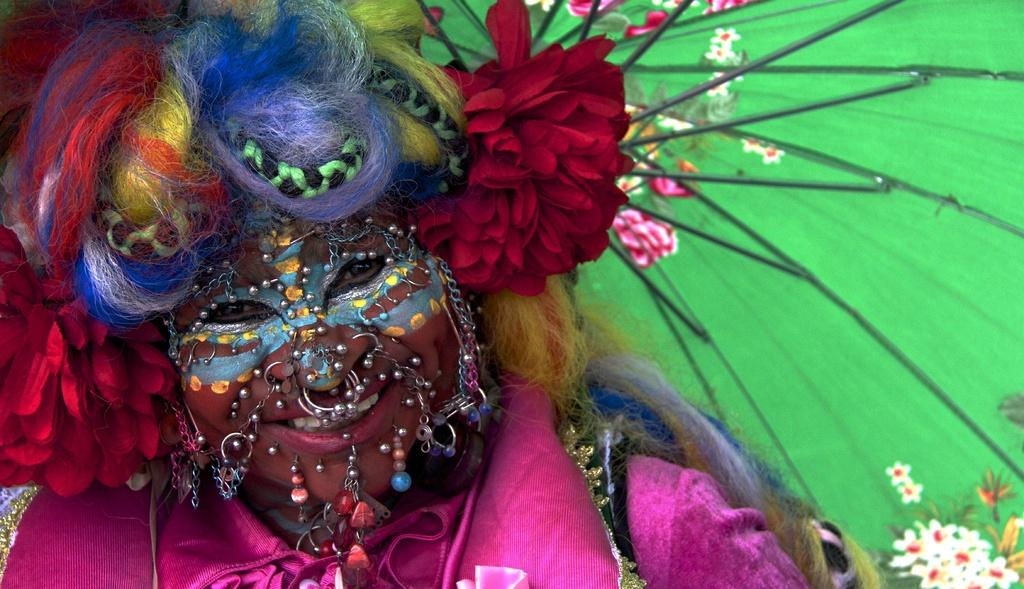Who is present in the image? There is a person in the image. What is the person wearing? The person is wearing a costume. What expression does the person have? The person is smiling. What object is the person holding? The person is holding an umbrella. What type of locket can be seen hanging from the person's finger in the image? There is no locket or finger visible in the image; the person is holding an umbrella. 